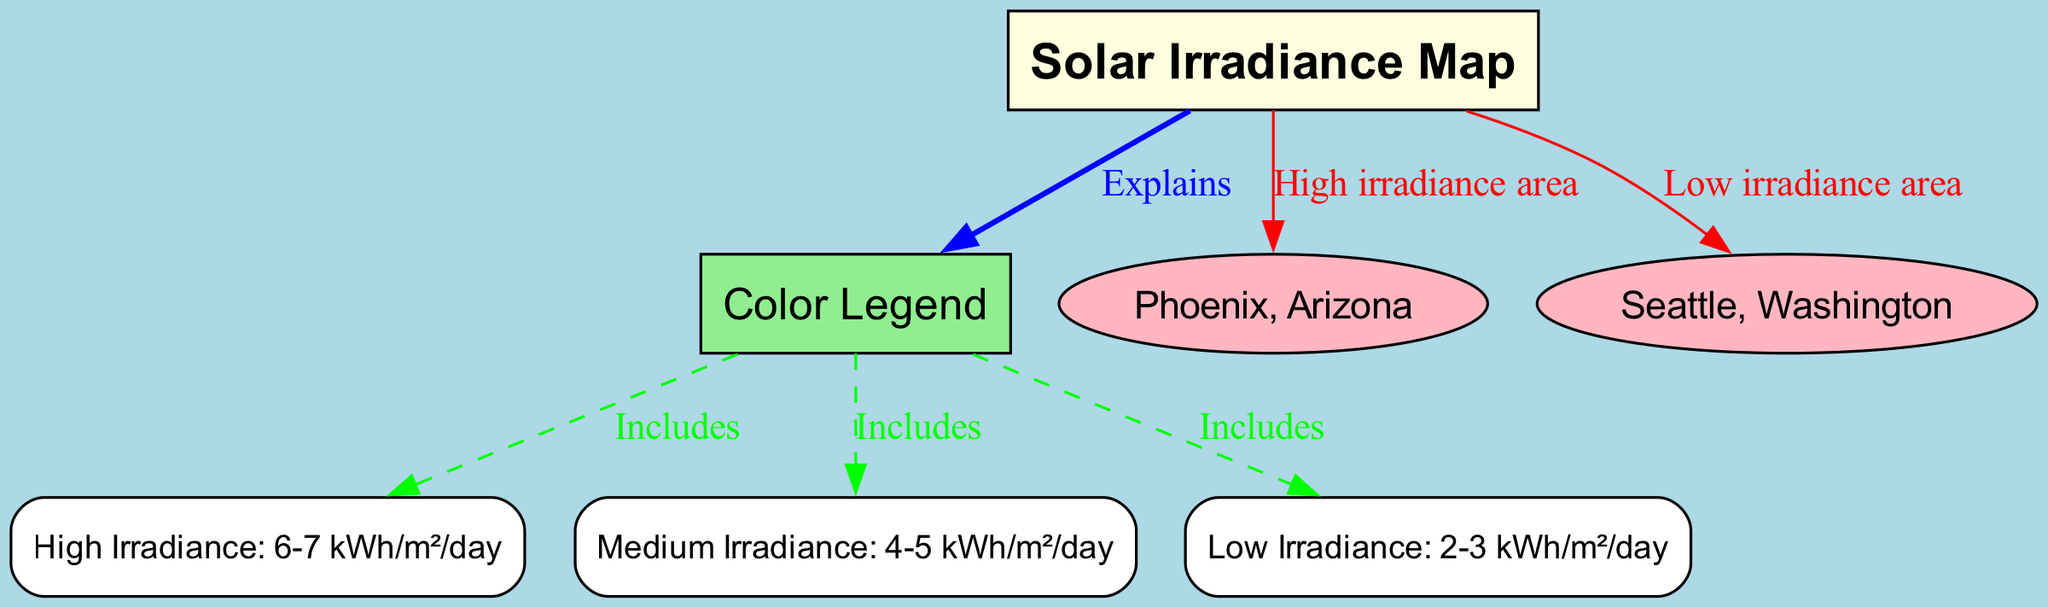What does the Solar Irradiance Map show? The Solar Irradiance Map displays the distribution of solar energy received in a specific region, represented in terms of irradiance levels.
Answer: Solar energy distribution What is the highest irradiance level indicated on the map? The map's legend states that the high irradiance level is defined as 6-7 kWh/m²/day.
Answer: 6-7 kWh/m²/day How many cities are identified in the map? There are two cities indicated in the map, which are Phoenix, Arizona, and Seattle, Washington.
Answer: 2 What color represents high irradiance in the legend? The legend includes colors of the irradiance levels, with high irradiance represented in a certain color, typically associated with the high category.
Answer: Light green Which city is indicated as having low irradiance? The map labels Seattle, Washington as the area with low irradiance based on the visual representation.
Answer: Seattle, Washington How is high irradiance represented in the diagram? The diagram specifies that high irradiance is classified under the high category in the legend, which is connected to the map to show its presence.
Answer: High category Which type of edge connects the Solar Irradiance Map to the Color Legend? The map is connected to the legend via an edge labeled "Explains," indicating that the legend provides an explanation for the information on the map.
Answer: Explains What does the edge labeled "Includes" signify? The "Includes" edge indicates that the legend contains different categories of irradiance levels such as high, medium, and low.
Answer: Categories of irradiance levels 